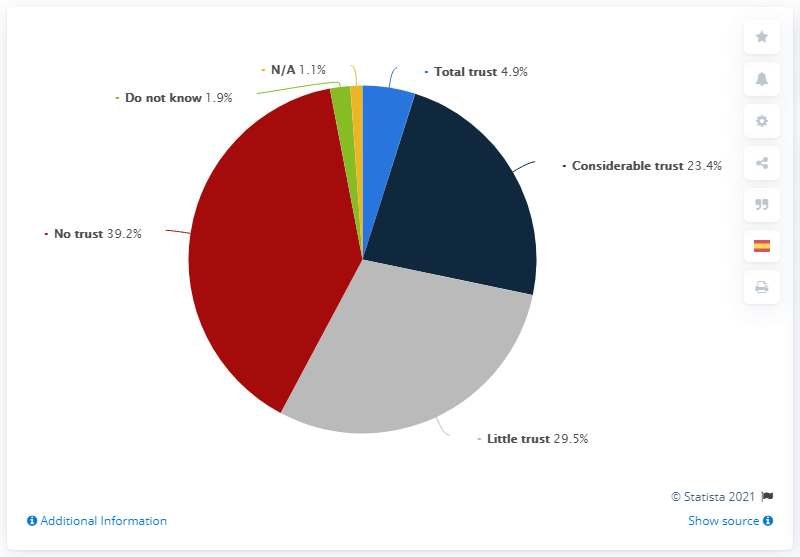What is the sum of the highest and lowest percentage in the chart?
 40.3 